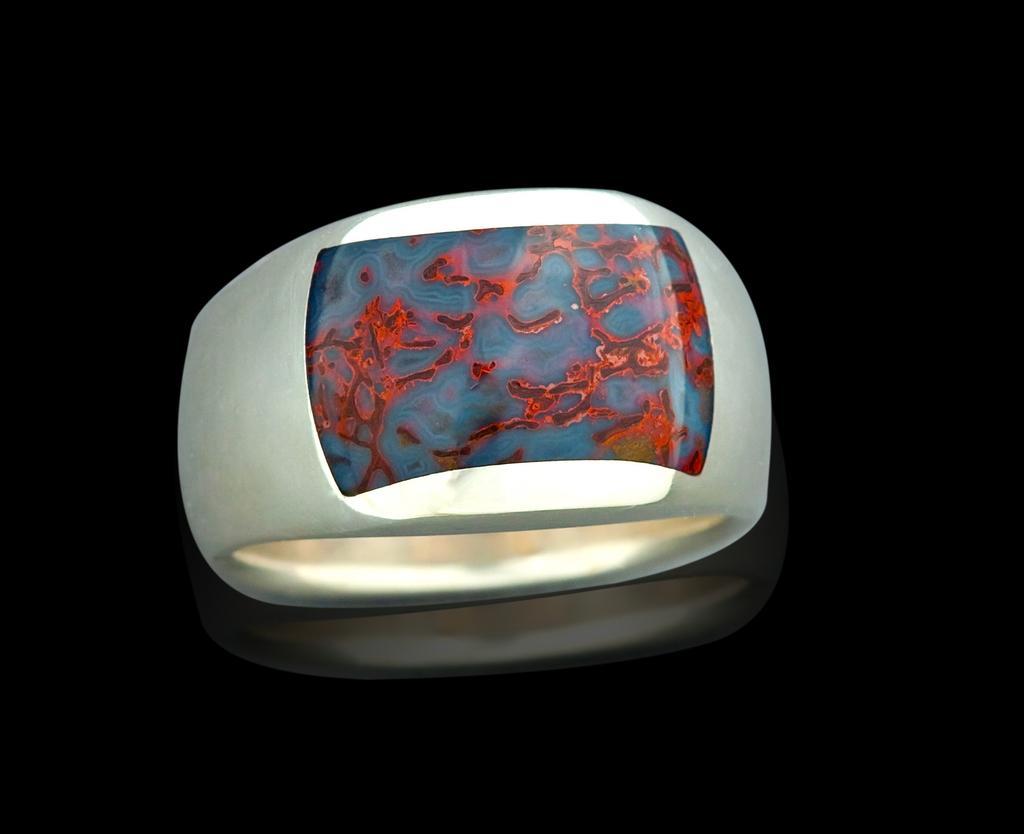Could you give a brief overview of what you see in this image? In this image we can see an object which looks like a ring with design and in the background, the image is dark. 